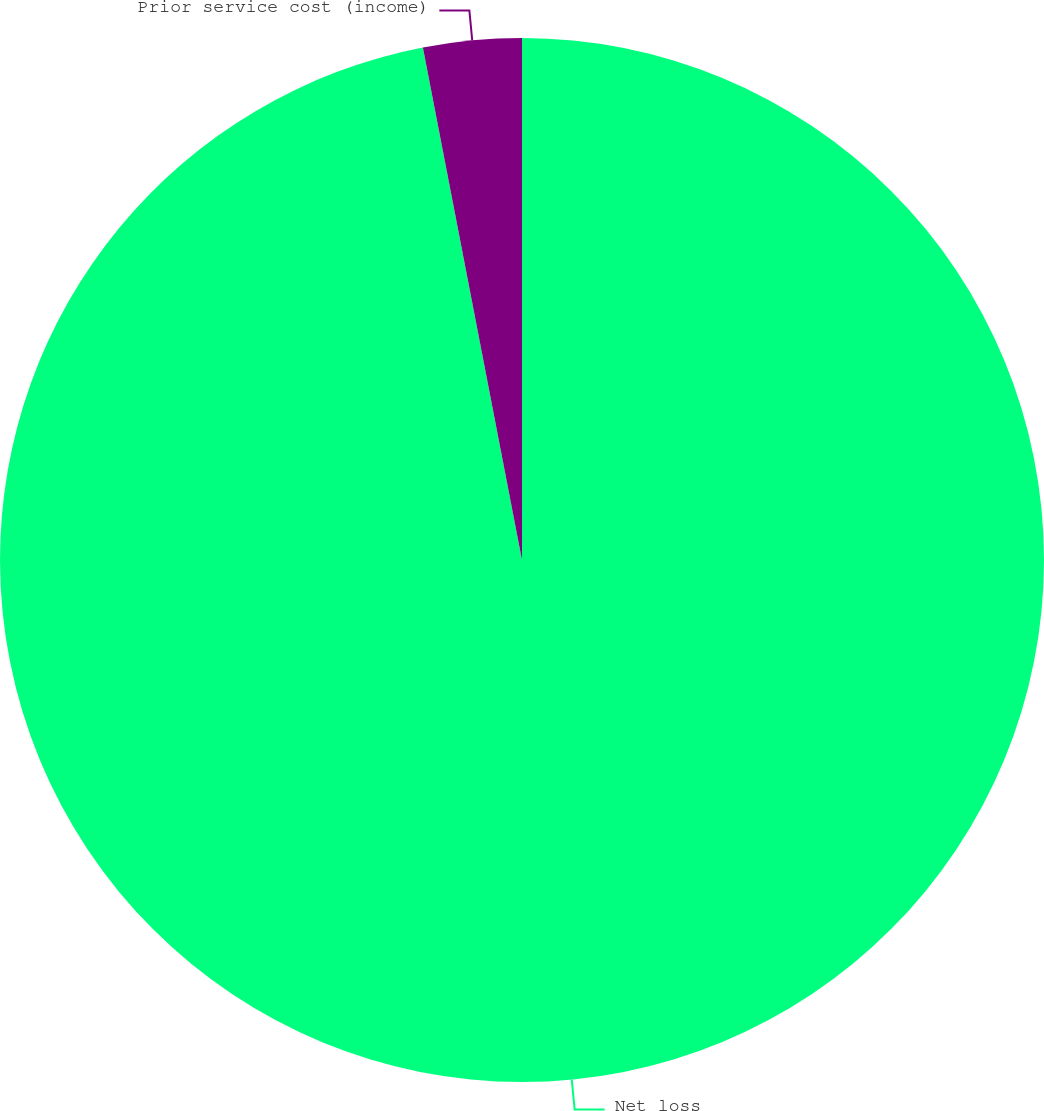Convert chart to OTSL. <chart><loc_0><loc_0><loc_500><loc_500><pie_chart><fcel>Net loss<fcel>Prior service cost (income)<nl><fcel>96.96%<fcel>3.04%<nl></chart> 